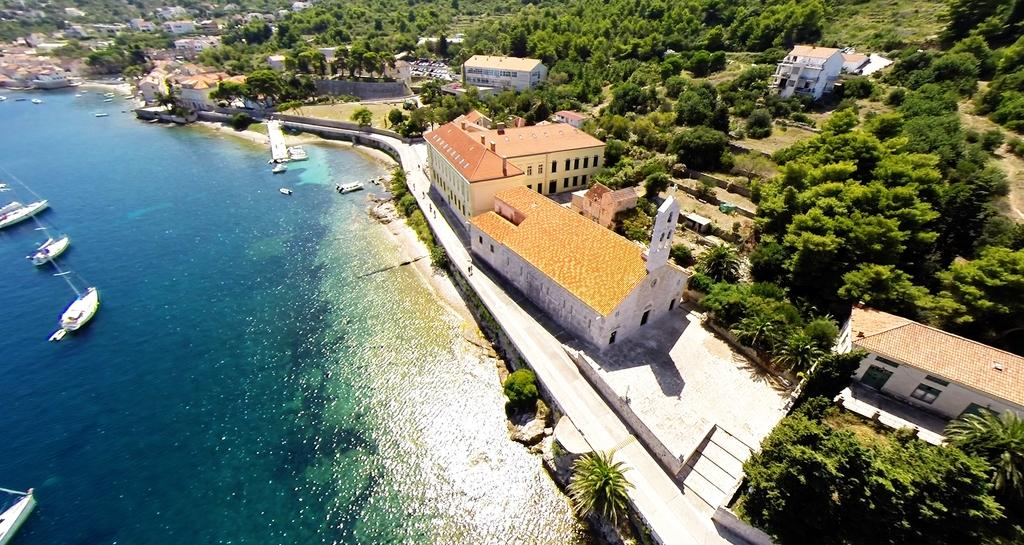What is located on the left side of the image? There is water on the left side of the image. What can be seen in the water? There are boats in the water. What type of vegetation is on the right side of the image? There are trees on the right side of the image. What type of structures are on the right side of the image? There are buildings on the right side of the image. Where is the hospital located in the image? There is no hospital present in the image. What type of pan can be seen in the image? There is no pan present in the image. 